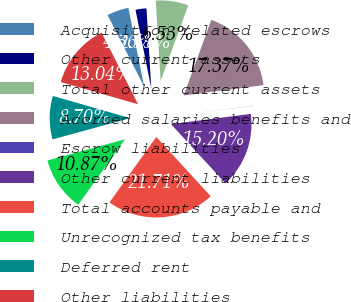Convert chart to OTSL. <chart><loc_0><loc_0><loc_500><loc_500><pie_chart><fcel>Acquisition related escrows<fcel>Other current assets<fcel>Total other current assets<fcel>Accrued salaries benefits and<fcel>Escrow liabilities<fcel>Other current liabilities<fcel>Total accounts payable and<fcel>Unrecognized tax benefits<fcel>Deferred rent<fcel>Other liabilities<nl><fcel>4.36%<fcel>2.19%<fcel>6.53%<fcel>17.37%<fcel>0.03%<fcel>15.2%<fcel>21.71%<fcel>10.87%<fcel>8.7%<fcel>13.04%<nl></chart> 